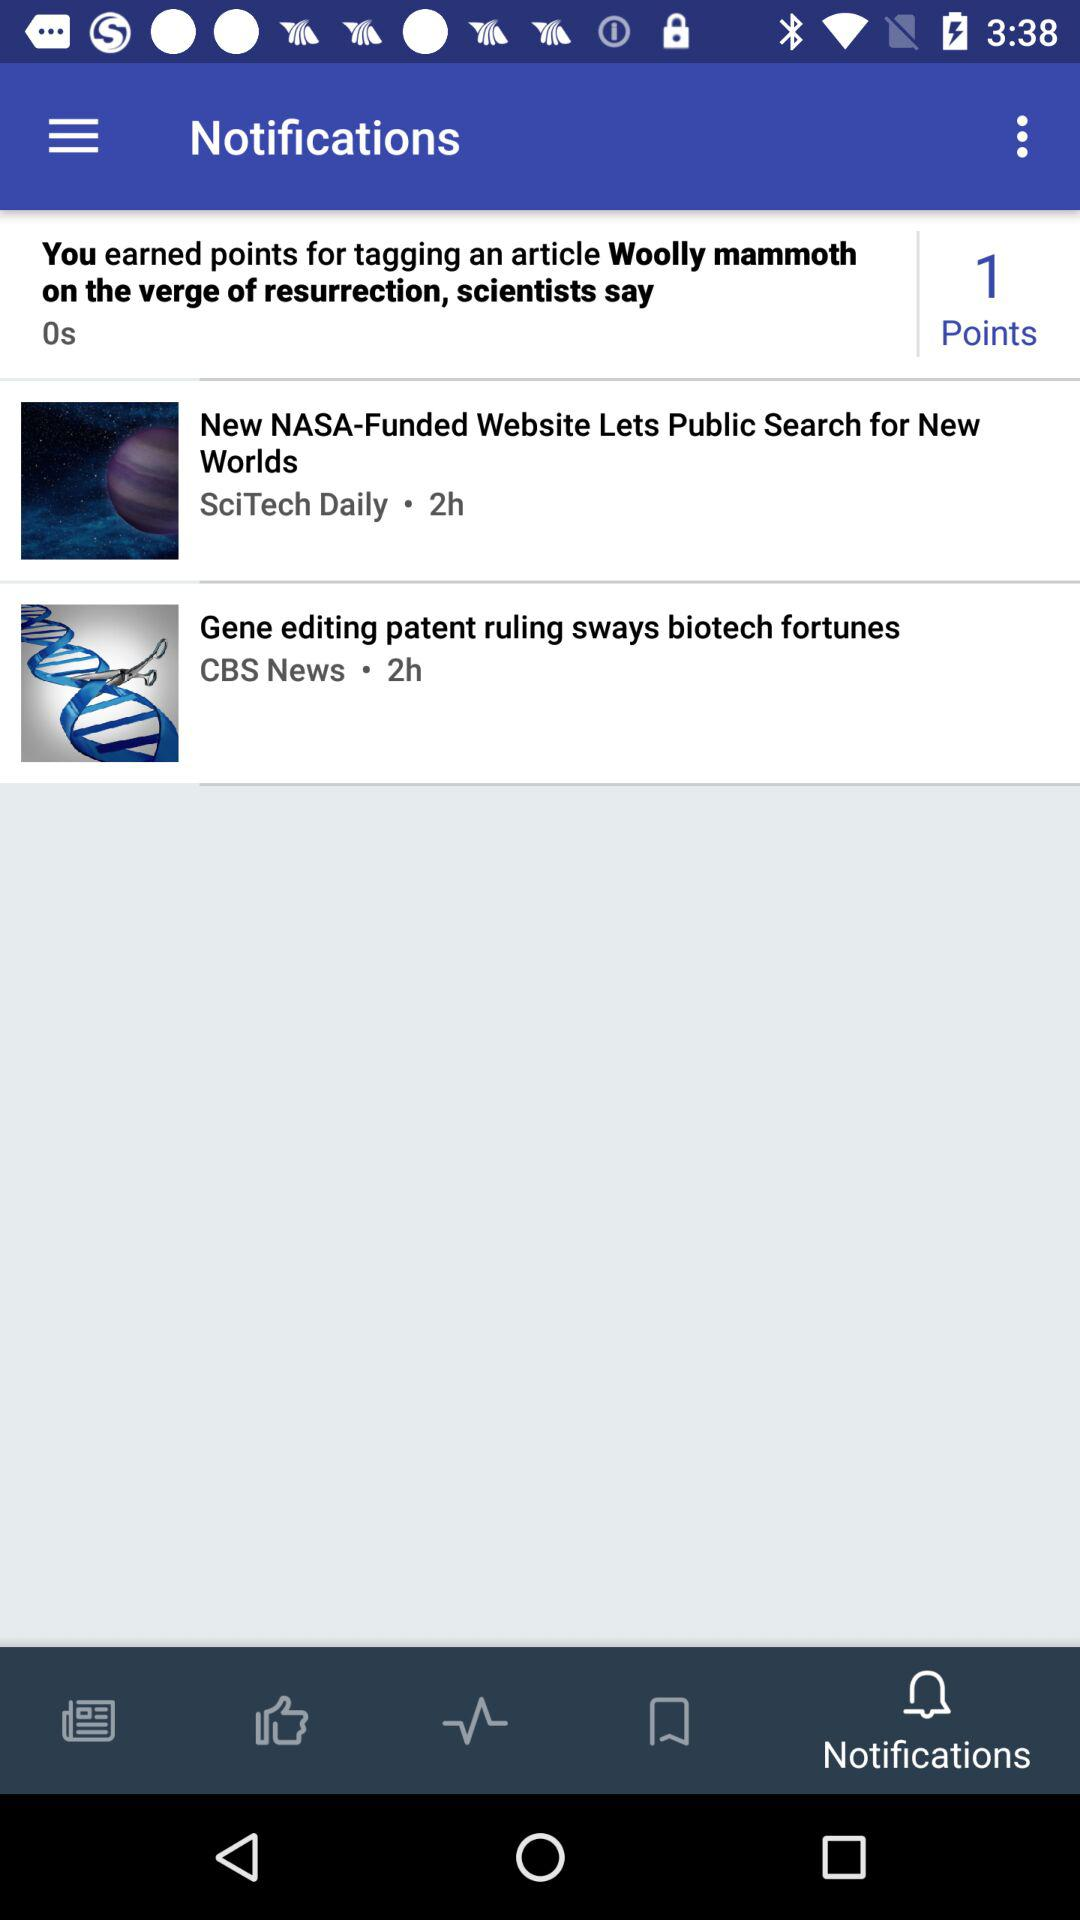Which tab is currently selected? The selected tab is notifications. 